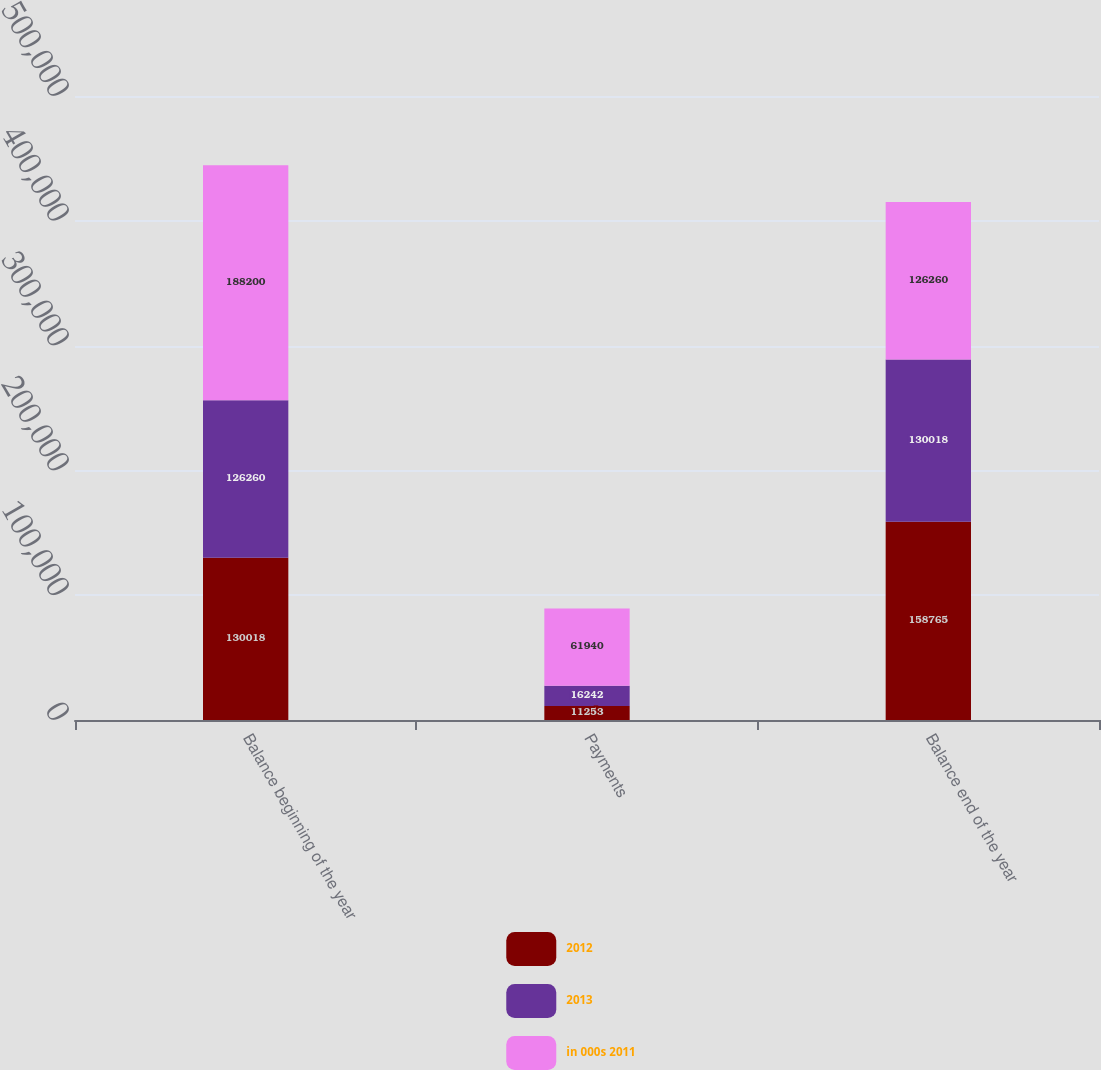<chart> <loc_0><loc_0><loc_500><loc_500><stacked_bar_chart><ecel><fcel>Balance beginning of the year<fcel>Payments<fcel>Balance end of the year<nl><fcel>2012<fcel>130018<fcel>11253<fcel>158765<nl><fcel>2013<fcel>126260<fcel>16242<fcel>130018<nl><fcel>in 000s 2011<fcel>188200<fcel>61940<fcel>126260<nl></chart> 